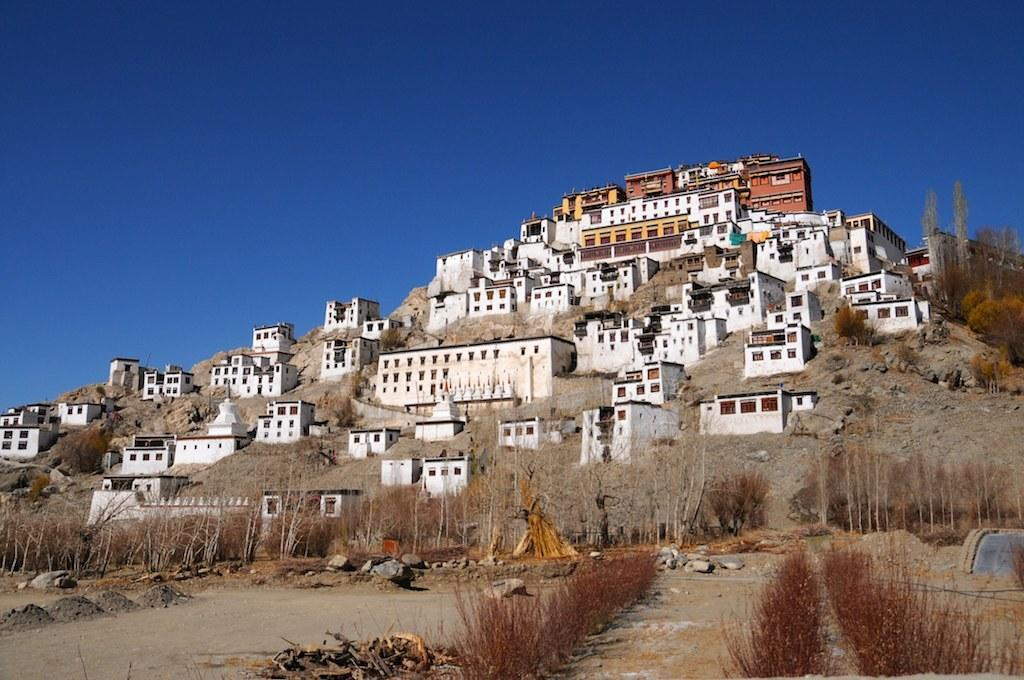What type of vegetation is present in the image? There are dried grass in the image. What can be seen in the background of the image? There are buildings in the background of the image. What colors are the buildings in the image? The buildings are in white and brown colors. What is the color of the sky in the image? The sky is blue in the image. Where is the cork located in the image? There is no cork present in the image. What type of medical facility can be seen in the image? There is no hospital or medical facility present in the image. 